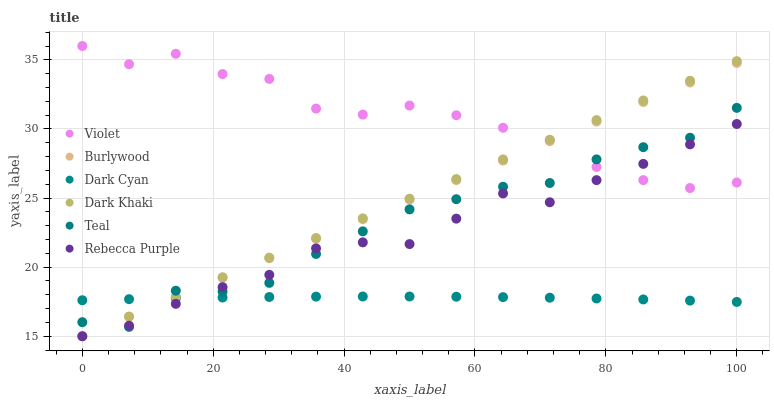Does Dark Cyan have the minimum area under the curve?
Answer yes or no. Yes. Does Violet have the maximum area under the curve?
Answer yes or no. Yes. Does Dark Khaki have the minimum area under the curve?
Answer yes or no. No. Does Dark Khaki have the maximum area under the curve?
Answer yes or no. No. Is Dark Khaki the smoothest?
Answer yes or no. Yes. Is Violet the roughest?
Answer yes or no. Yes. Is Rebecca Purple the smoothest?
Answer yes or no. No. Is Rebecca Purple the roughest?
Answer yes or no. No. Does Burlywood have the lowest value?
Answer yes or no. Yes. Does Teal have the lowest value?
Answer yes or no. No. Does Violet have the highest value?
Answer yes or no. Yes. Does Dark Khaki have the highest value?
Answer yes or no. No. Is Dark Cyan less than Violet?
Answer yes or no. Yes. Is Violet greater than Dark Cyan?
Answer yes or no. Yes. Does Teal intersect Rebecca Purple?
Answer yes or no. Yes. Is Teal less than Rebecca Purple?
Answer yes or no. No. Is Teal greater than Rebecca Purple?
Answer yes or no. No. Does Dark Cyan intersect Violet?
Answer yes or no. No. 